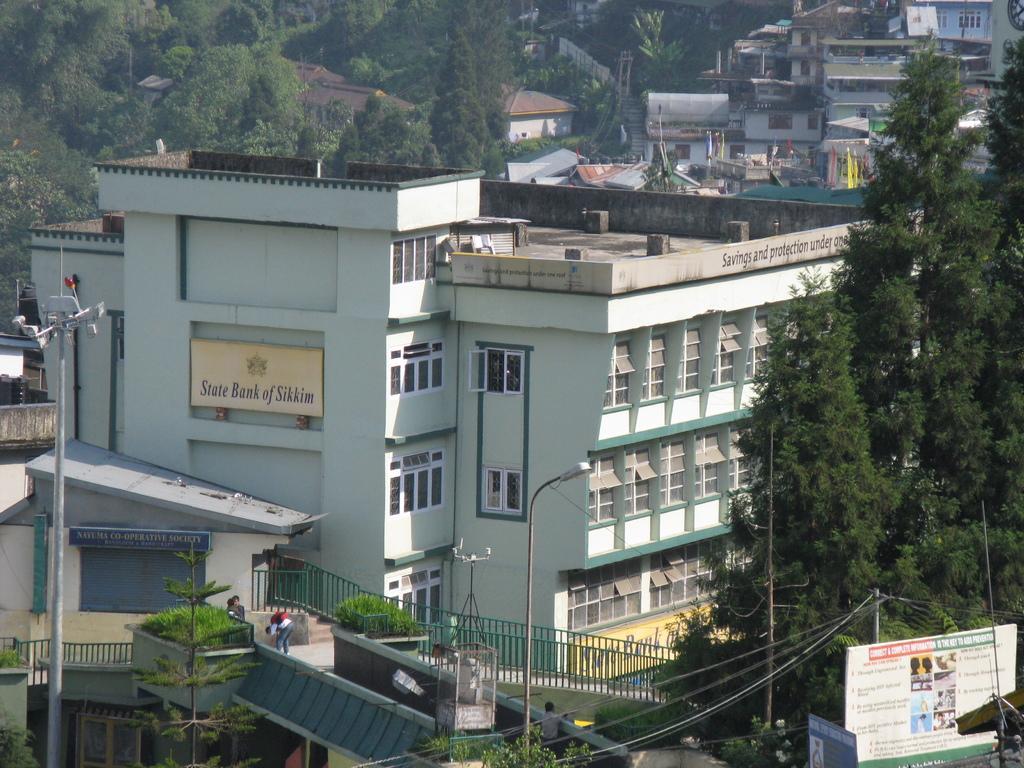Could you give a brief overview of what you see in this image? In this picture we can see the top view of the city with many buildings, trees, houses and poles. 